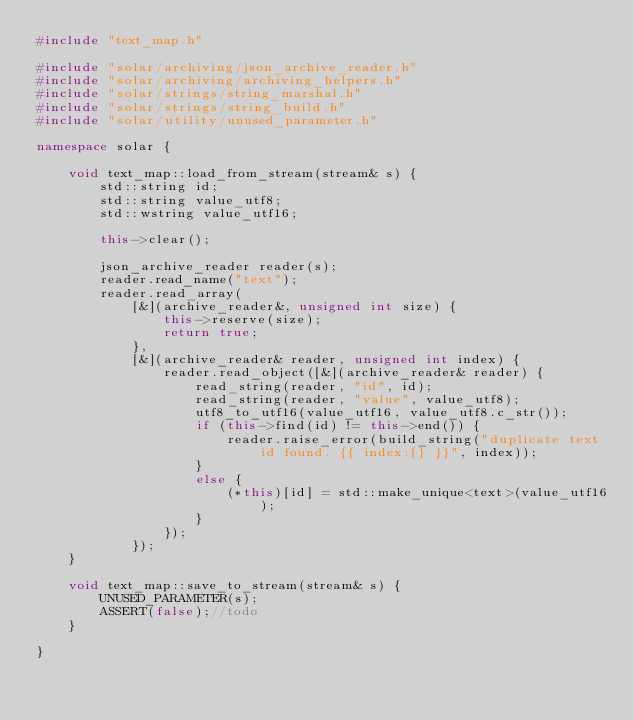<code> <loc_0><loc_0><loc_500><loc_500><_C++_>#include "text_map.h"

#include "solar/archiving/json_archive_reader.h"
#include "solar/archiving/archiving_helpers.h"
#include "solar/strings/string_marshal.h"
#include "solar/strings/string_build.h"
#include "solar/utility/unused_parameter.h"

namespace solar {

	void text_map::load_from_stream(stream& s) {
		std::string id;
		std::string value_utf8;
		std::wstring value_utf16;

		this->clear();

		json_archive_reader reader(s);
		reader.read_name("text");
		reader.read_array(
			[&](archive_reader&, unsigned int size) {
				this->reserve(size);
				return true;
			},
			[&](archive_reader& reader, unsigned int index) {
				reader.read_object([&](archive_reader& reader) {
					read_string(reader, "id", id);
					read_string(reader, "value", value_utf8);
					utf8_to_utf16(value_utf16, value_utf8.c_str());
					if (this->find(id) != this->end()) {
						reader.raise_error(build_string("duplicate text id found. {{ index:{} }}", index));
					}
					else {
						(*this)[id] = std::make_unique<text>(value_utf16);
					}
				});
			});
	}

	void text_map::save_to_stream(stream& s) {
		UNUSED_PARAMETER(s);
		ASSERT(false);//todo
	}

}</code> 